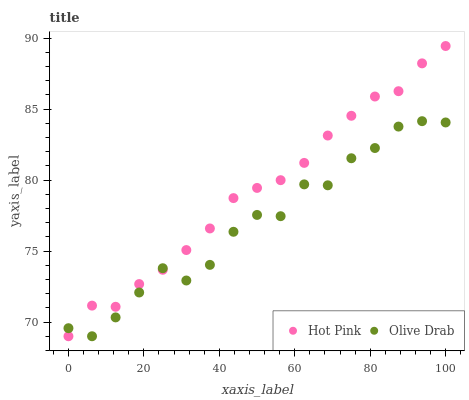Does Olive Drab have the minimum area under the curve?
Answer yes or no. Yes. Does Hot Pink have the maximum area under the curve?
Answer yes or no. Yes. Does Olive Drab have the maximum area under the curve?
Answer yes or no. No. Is Hot Pink the smoothest?
Answer yes or no. Yes. Is Olive Drab the roughest?
Answer yes or no. Yes. Is Olive Drab the smoothest?
Answer yes or no. No. Does Hot Pink have the lowest value?
Answer yes or no. Yes. Does Hot Pink have the highest value?
Answer yes or no. Yes. Does Olive Drab have the highest value?
Answer yes or no. No. Does Olive Drab intersect Hot Pink?
Answer yes or no. Yes. Is Olive Drab less than Hot Pink?
Answer yes or no. No. Is Olive Drab greater than Hot Pink?
Answer yes or no. No. 